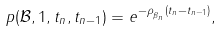<formula> <loc_0><loc_0><loc_500><loc_500>p ( \mathcal { B } , 1 , t _ { n } , t _ { n - 1 } ) = e ^ { - \rho _ { _ { \beta _ { n } } } ( t _ { n } - t _ { n - 1 } ) } ,</formula> 